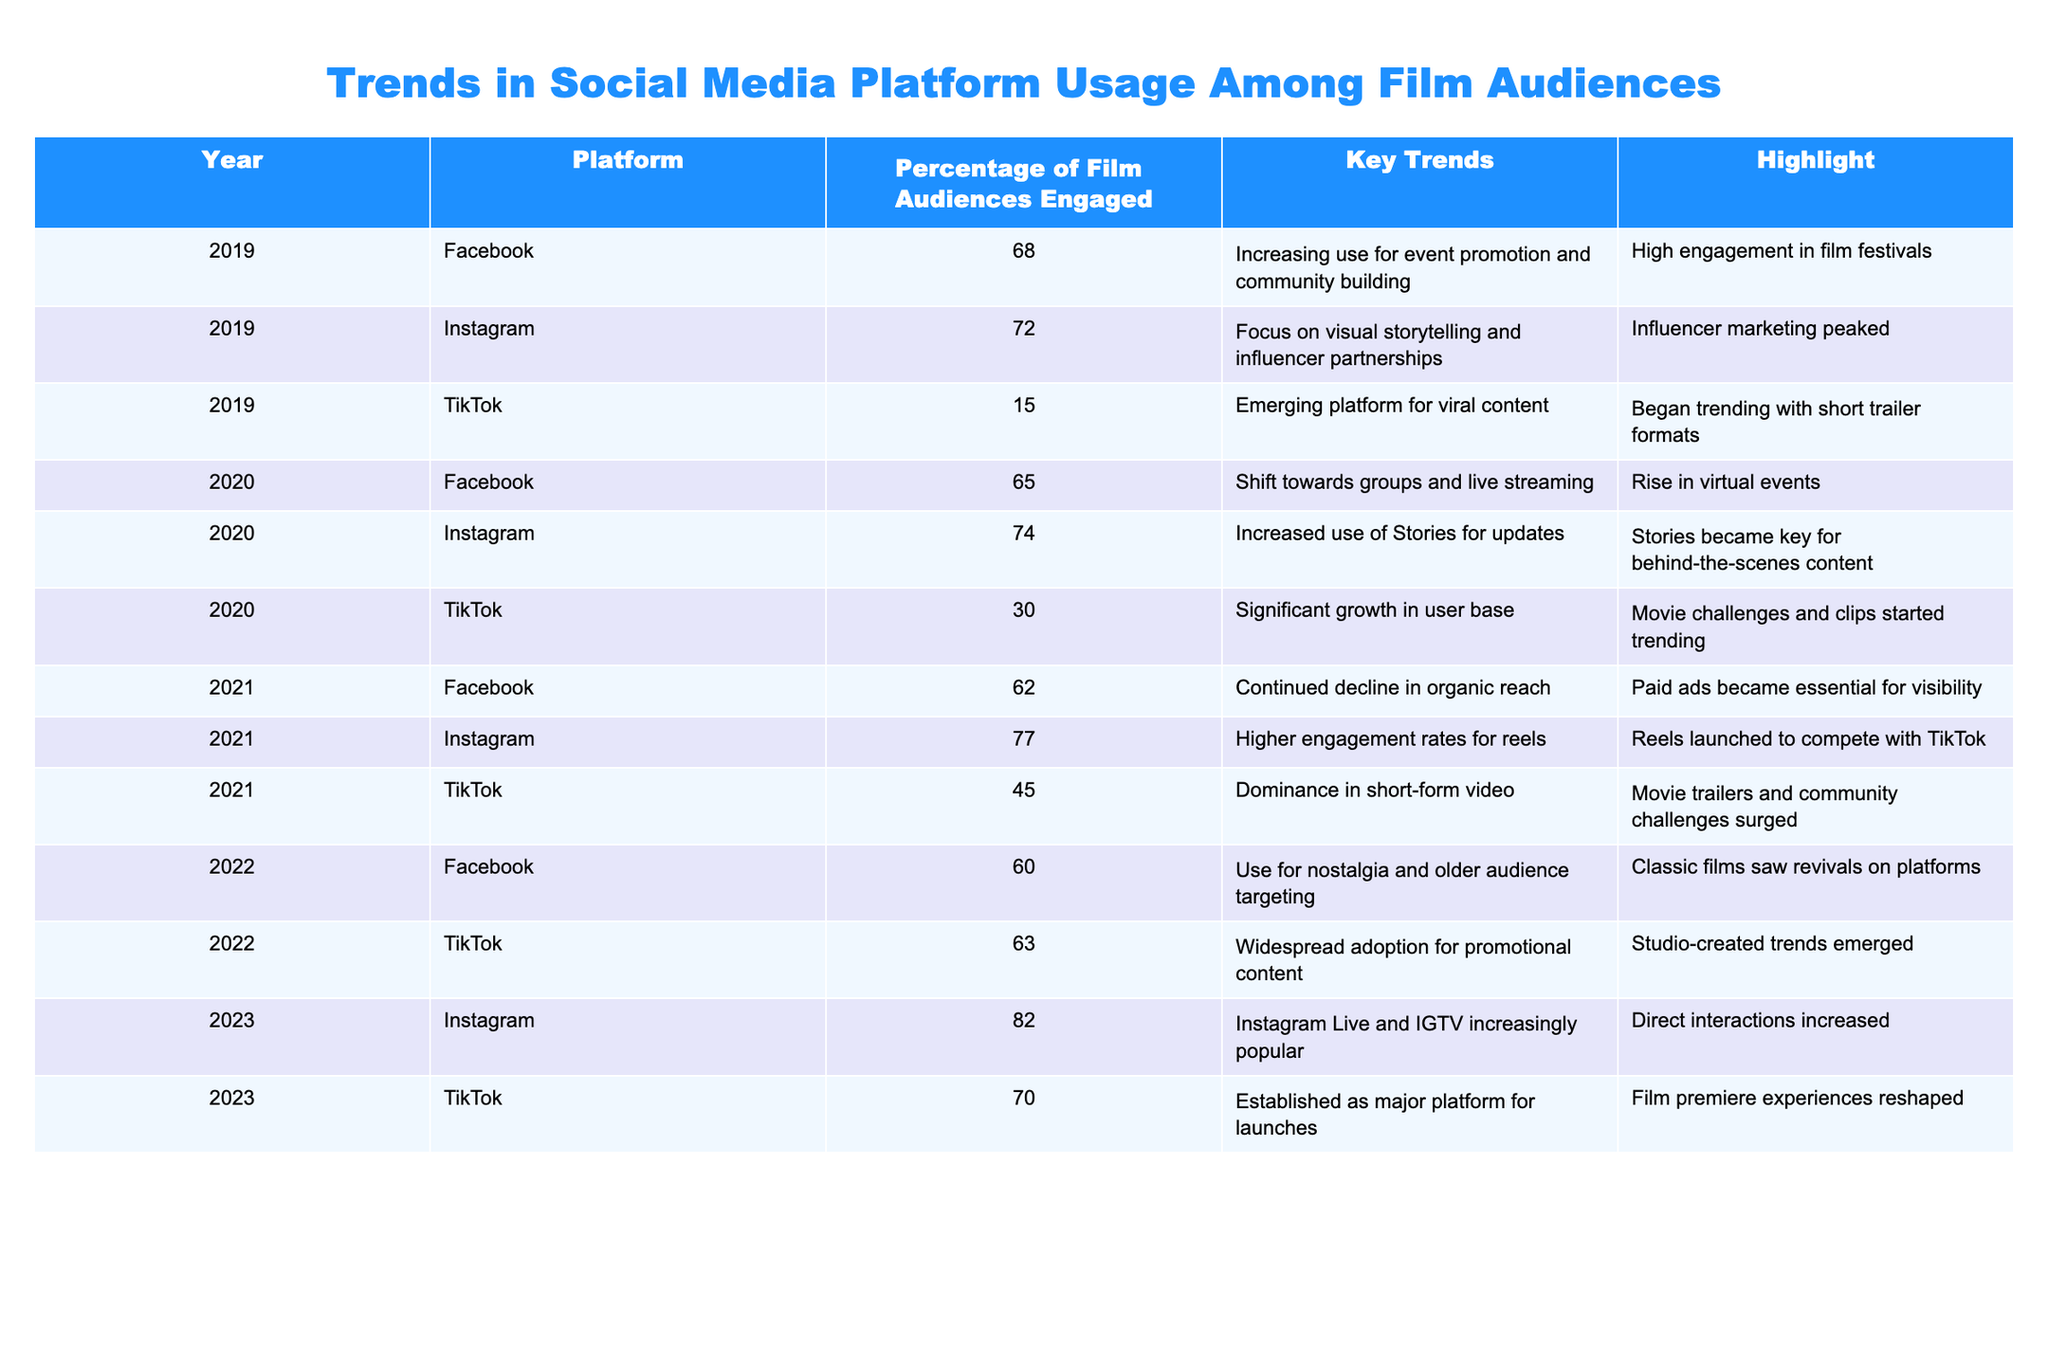What was the percentage of film audiences engaged on Instagram in 2023? The table shows that in 2023, the percentage of film audiences engaged on Instagram was 82%.
Answer: 82% Which platform had the highest percentage of engagement in 2021? According to the table, Instagram had the highest percentage of engagement in 2021 at 77%.
Answer: Instagram, 77% What is the trend in TikTok engagement from 2020 to 2023? TikTok engagement increased from 30% in 2020 to 70% in 2023, indicating a significant upward trend over these years.
Answer: Increased from 30% to 70% Did Facebook's engagement percentage increase or decrease from 2019 to 2022? The table shows a decrease in Facebook's engagement from 68% in 2019 to 60% in 2022. Therefore, it decreased.
Answer: Decreased What was the average percentage of film audience engagement for Instagram across the years listed? The engagement percentages for Instagram are 72%, 74%, 77%, 82%. Summing them gives 305%, and dividing by 4 (the number of years) results in an average of 76.25%.
Answer: 76.25% In 2022, was TikTok more engaged with film audiences compared to Facebook? The table indicates TikTok had a 63% engagement, while Facebook had only 60% in 2022. Therefore, TikTok had higher engagement.
Answer: Yes How much did TikTok's engagement grow from 2020 to 2021? TikTok's engagement increased from 30% in 2020 to 45% in 2021. The growth is calculated as 45% - 30% = 15%.
Answer: 15% What was the trend observed for Facebook in 2021 regarding organic reach? The table states that Facebook continued to decline in organic reach in 2021, indicating a negative trend.
Answer: Declined Which year saw Instagram Stories becoming a critical feature for film content? The table indicates that Instagram Stories became key for behind-the-scenes content in 2020, making that the year of significant focus.
Answer: 2020 What was the change in engagement percentage on TikTok from 2021 to 2022? TikTok's engagement was 45% in 2021 and increased to 63% in 2022, resulting in a change of 63% - 45% = 18%.
Answer: Increased by 18% 